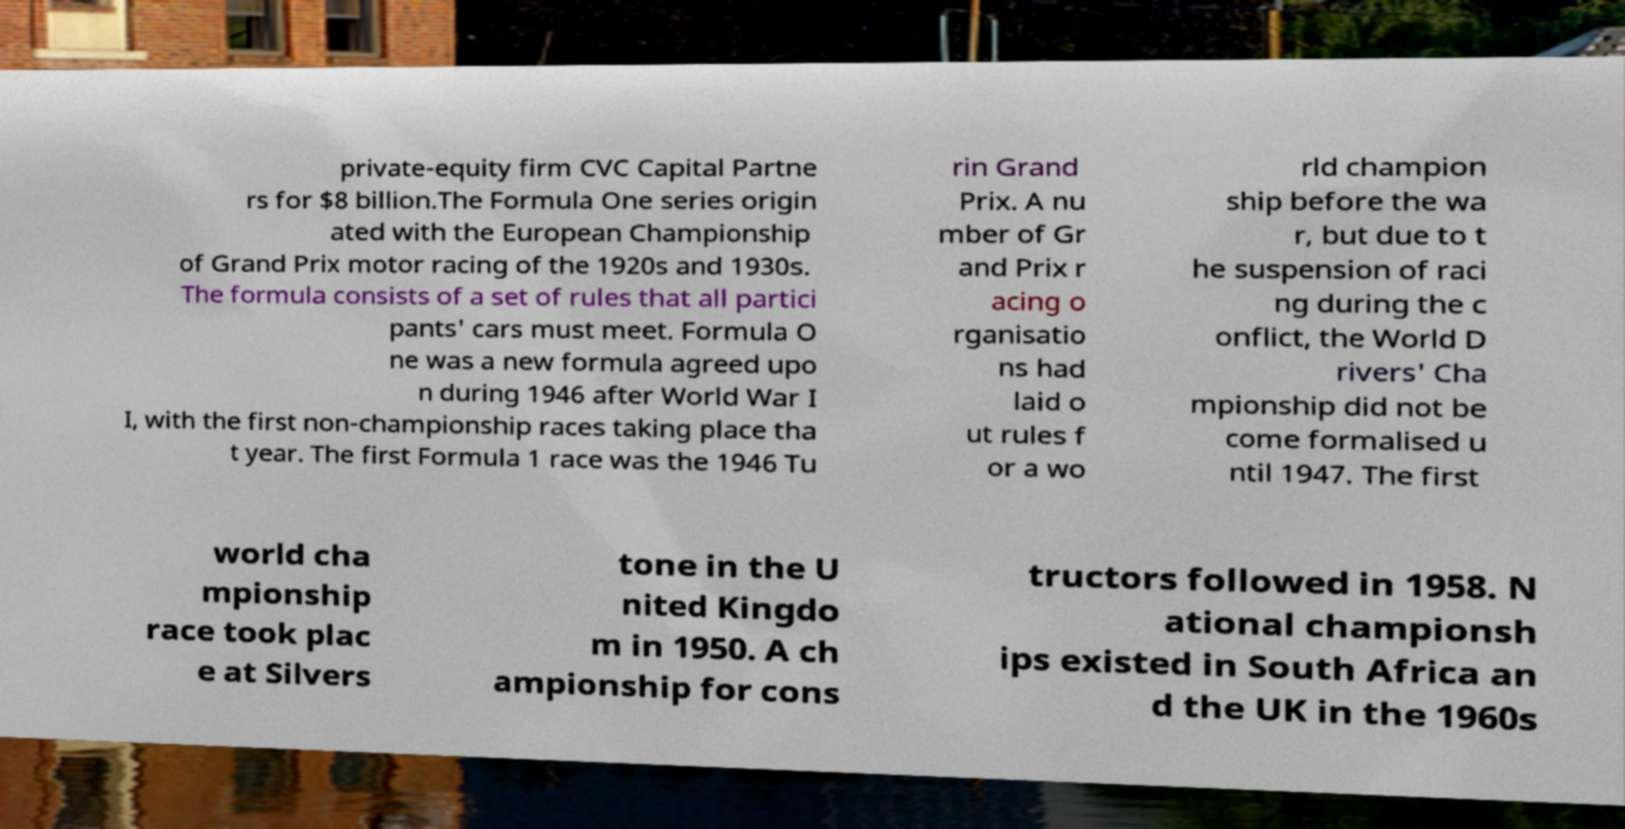I need the written content from this picture converted into text. Can you do that? private-equity firm CVC Capital Partne rs for $8 billion.The Formula One series origin ated with the European Championship of Grand Prix motor racing of the 1920s and 1930s. The formula consists of a set of rules that all partici pants' cars must meet. Formula O ne was a new formula agreed upo n during 1946 after World War I I, with the first non-championship races taking place tha t year. The first Formula 1 race was the 1946 Tu rin Grand Prix. A nu mber of Gr and Prix r acing o rganisatio ns had laid o ut rules f or a wo rld champion ship before the wa r, but due to t he suspension of raci ng during the c onflict, the World D rivers' Cha mpionship did not be come formalised u ntil 1947. The first world cha mpionship race took plac e at Silvers tone in the U nited Kingdo m in 1950. A ch ampionship for cons tructors followed in 1958. N ational championsh ips existed in South Africa an d the UK in the 1960s 